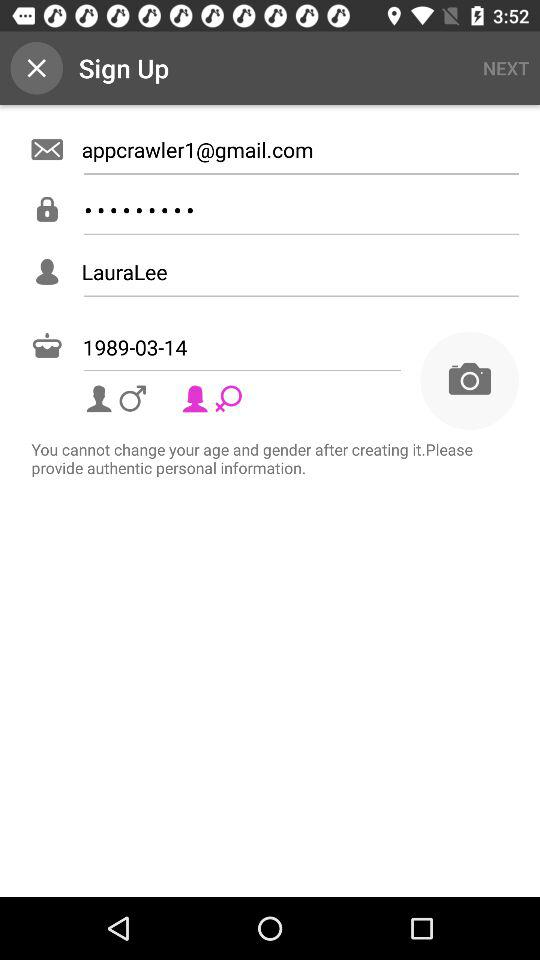What's the date of birth? The date of birth is 1989-03-14. 